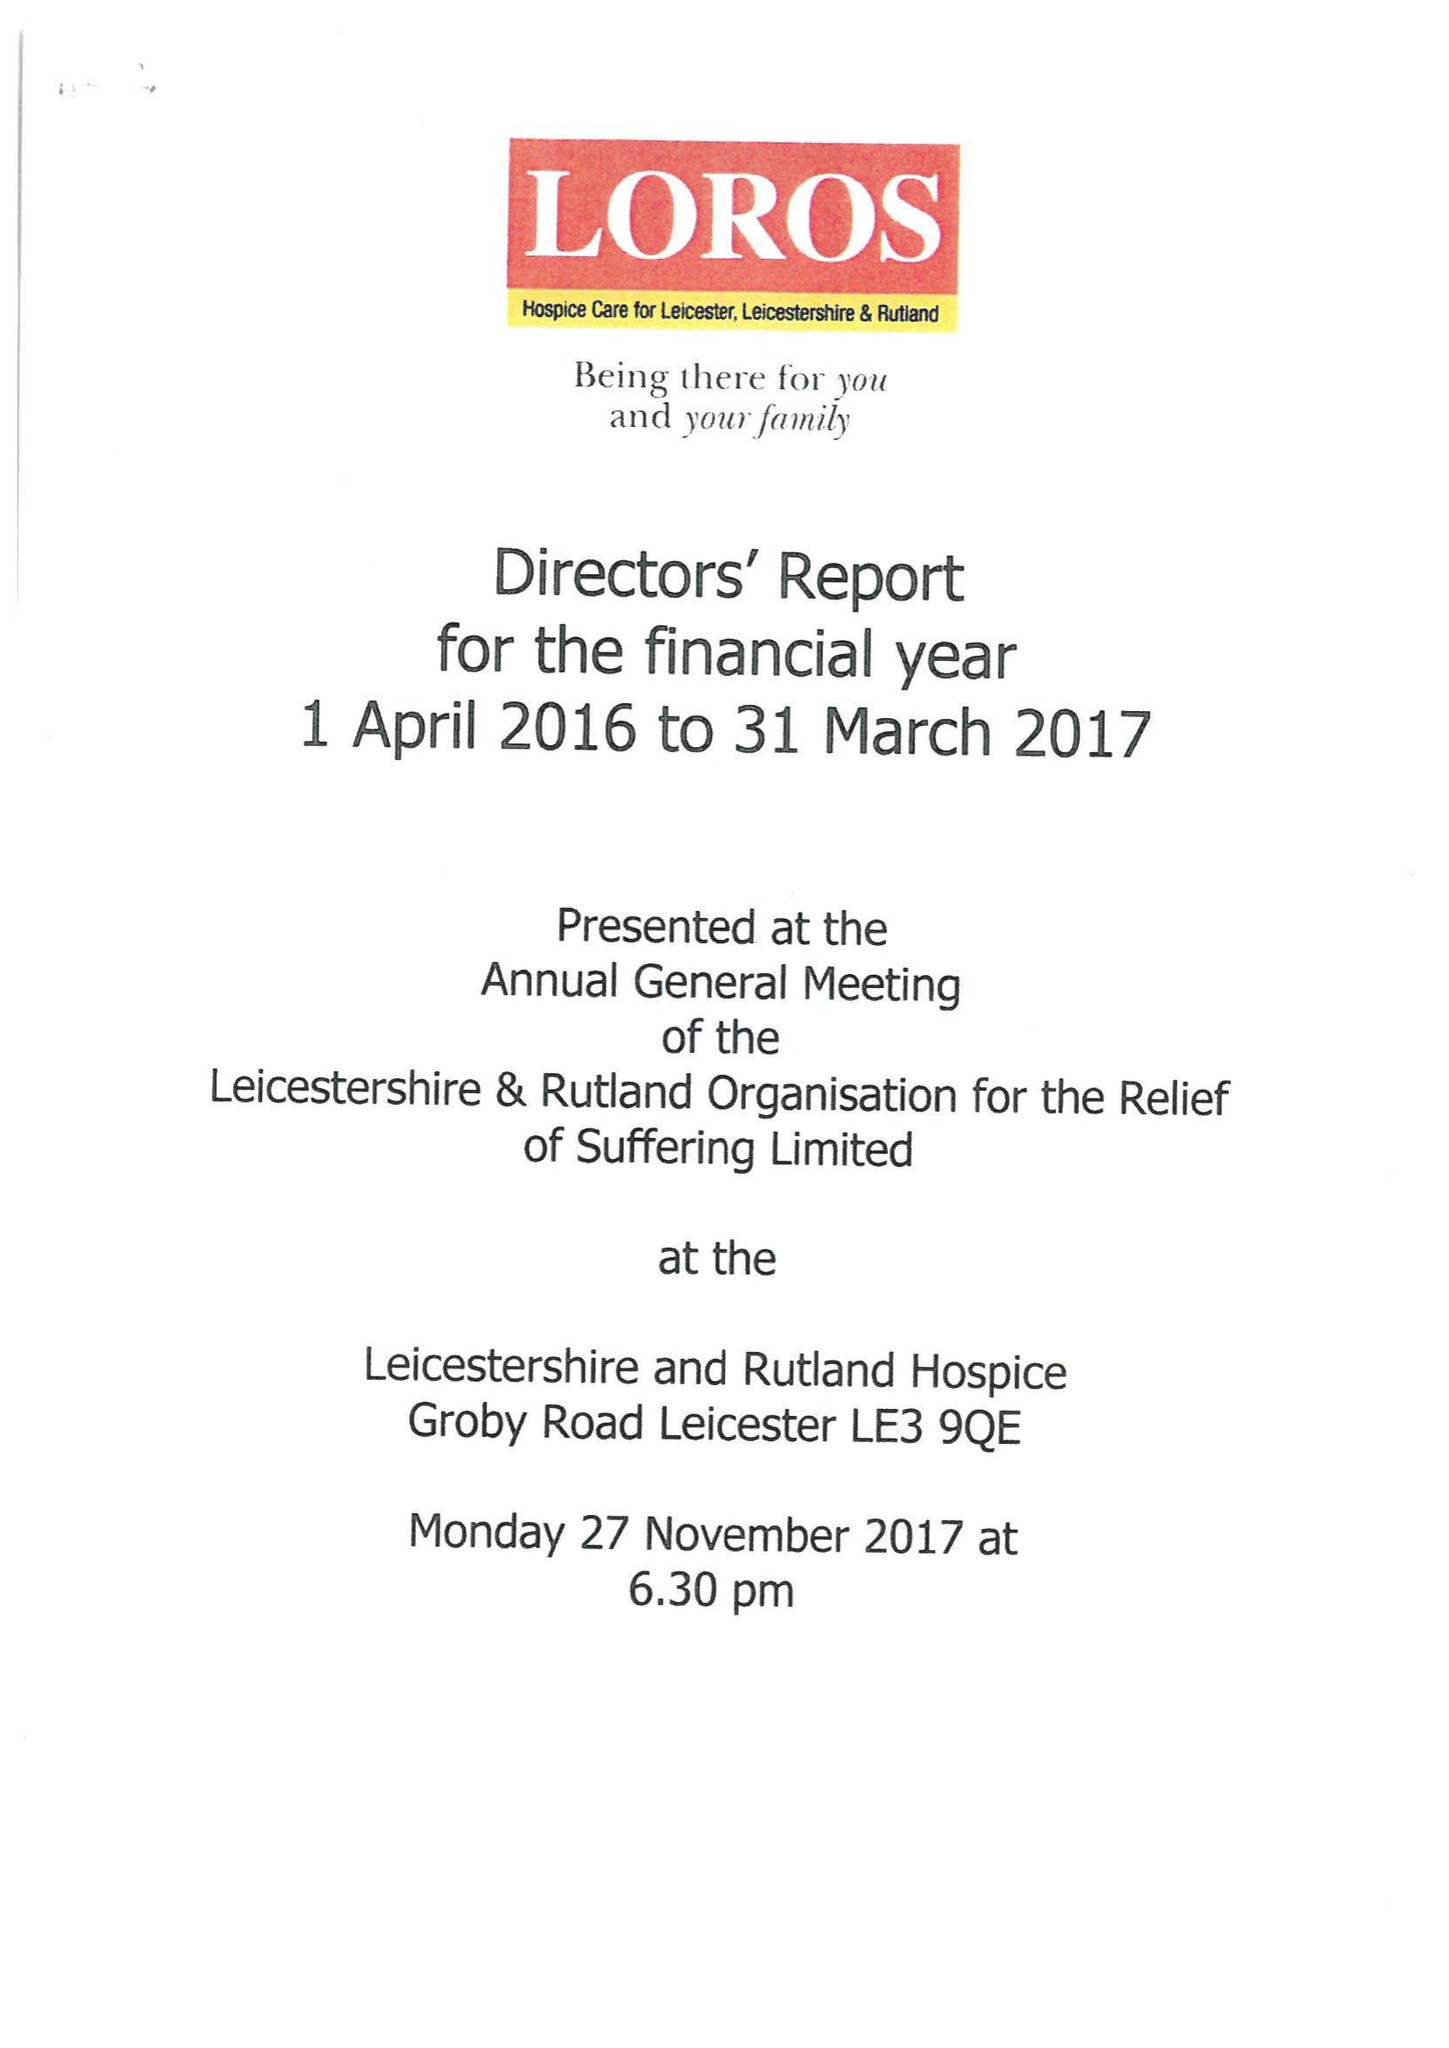What is the value for the report_date?
Answer the question using a single word or phrase. 2017-03-31 